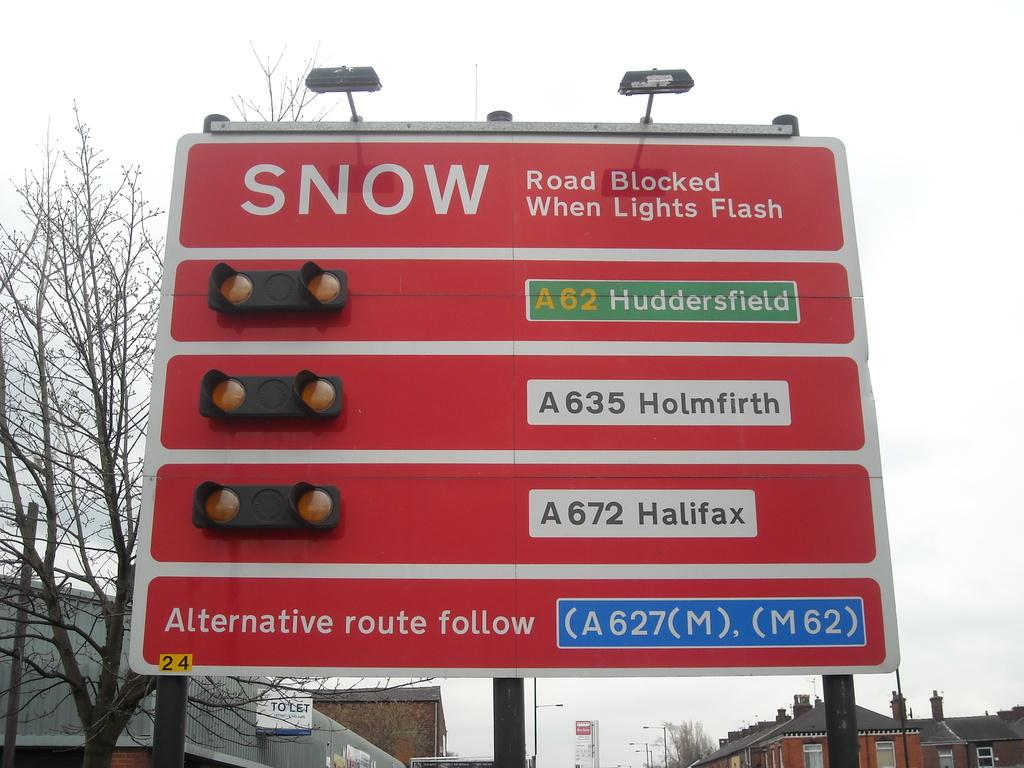<image>
Offer a succinct explanation of the picture presented. A street sign that flashes for lights for Huddersfield, Holmfirth, and Halifax if the roads are blocked by snow. 